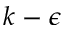<formula> <loc_0><loc_0><loc_500><loc_500>k - \epsilon</formula> 